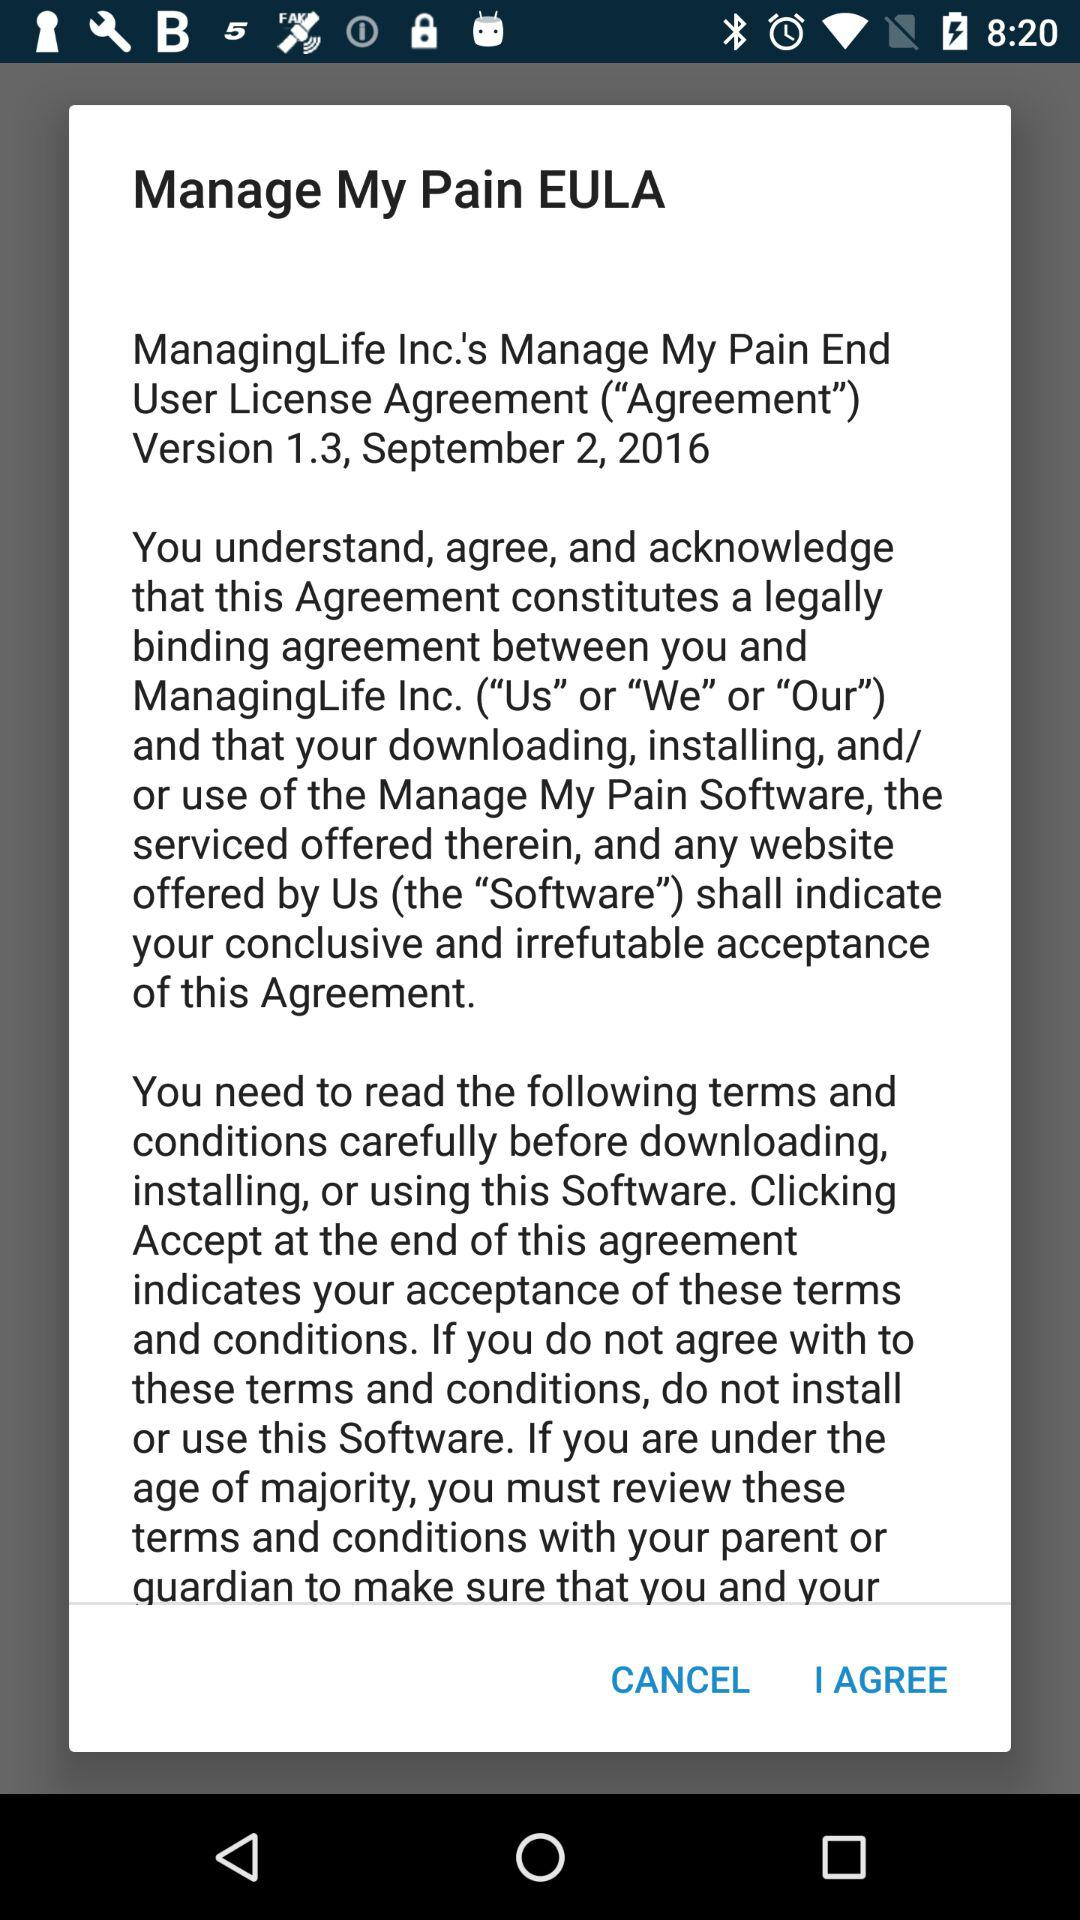What is the given version? The given version is 1.3. 